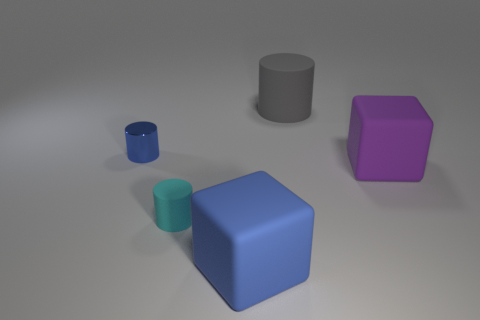Add 4 small green rubber spheres. How many objects exist? 9 Subtract 0 gray blocks. How many objects are left? 5 Subtract all cubes. How many objects are left? 3 Subtract all blue blocks. Subtract all large purple cubes. How many objects are left? 3 Add 1 blue cylinders. How many blue cylinders are left? 2 Add 2 metallic objects. How many metallic objects exist? 3 